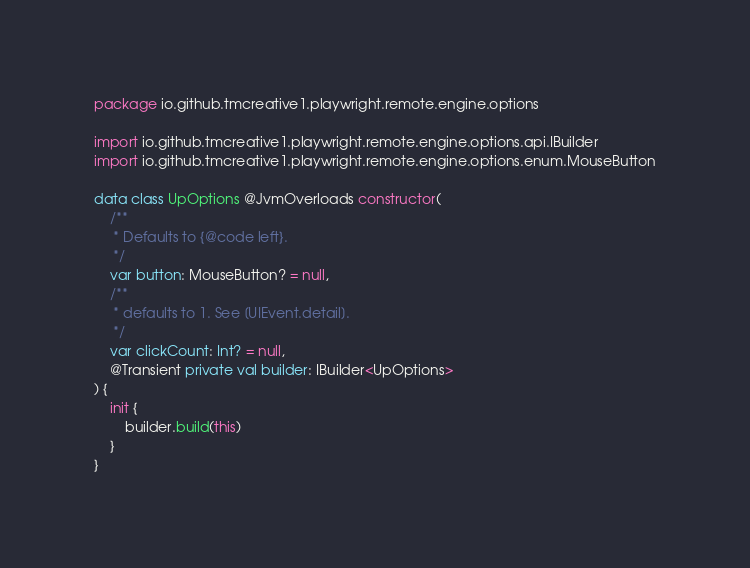<code> <loc_0><loc_0><loc_500><loc_500><_Kotlin_>package io.github.tmcreative1.playwright.remote.engine.options

import io.github.tmcreative1.playwright.remote.engine.options.api.IBuilder
import io.github.tmcreative1.playwright.remote.engine.options.enum.MouseButton

data class UpOptions @JvmOverloads constructor(
    /**
     * Defaults to {@code left}.
     */
    var button: MouseButton? = null,
    /**
     * defaults to 1. See [UIEvent.detail].
     */
    var clickCount: Int? = null,
    @Transient private val builder: IBuilder<UpOptions>
) {
    init {
        builder.build(this)
    }
}</code> 